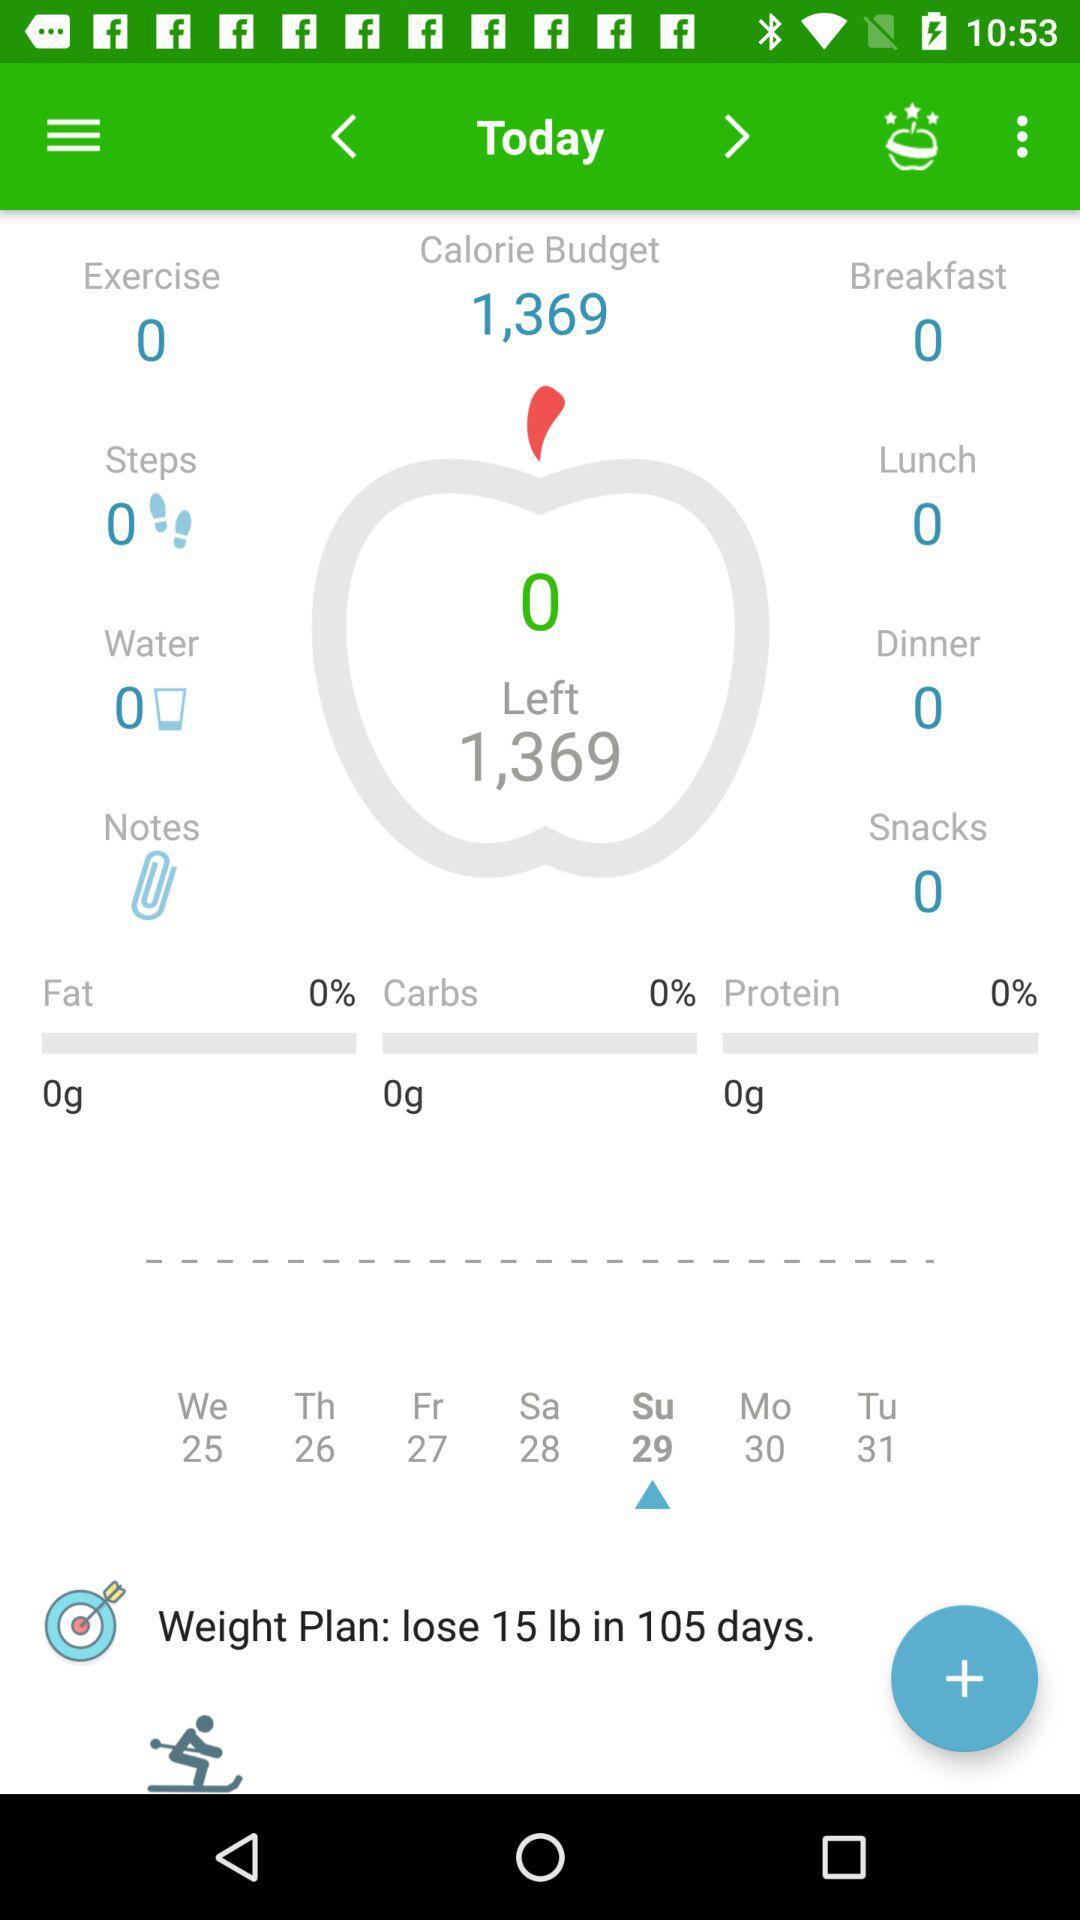What is the number of snacks given? The number of snacks given is 0. 